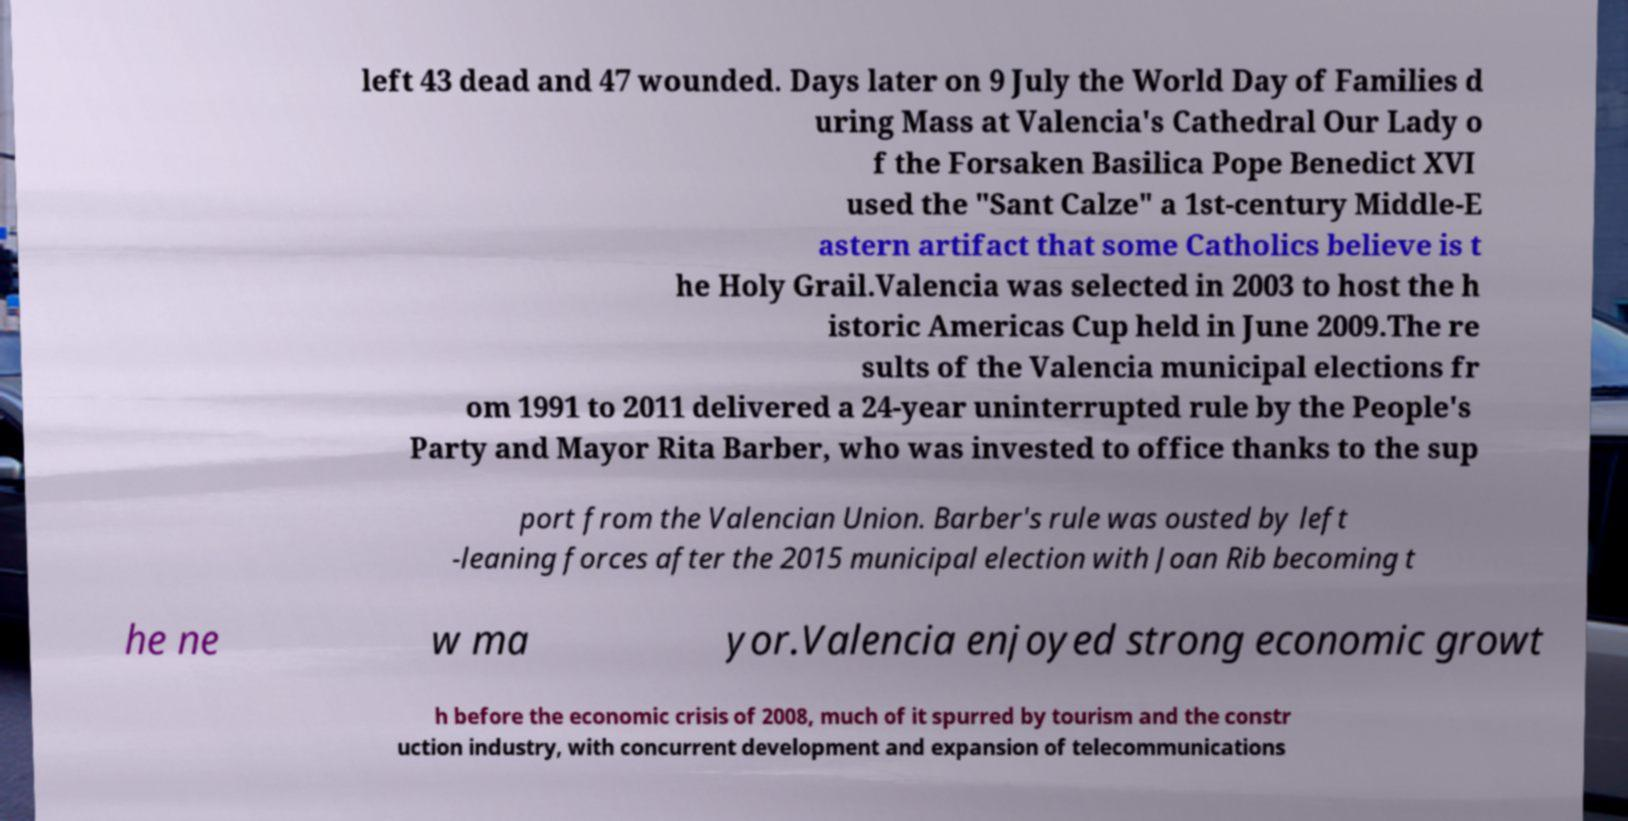Could you assist in decoding the text presented in this image and type it out clearly? left 43 dead and 47 wounded. Days later on 9 July the World Day of Families d uring Mass at Valencia's Cathedral Our Lady o f the Forsaken Basilica Pope Benedict XVI used the "Sant Calze" a 1st-century Middle-E astern artifact that some Catholics believe is t he Holy Grail.Valencia was selected in 2003 to host the h istoric Americas Cup held in June 2009.The re sults of the Valencia municipal elections fr om 1991 to 2011 delivered a 24-year uninterrupted rule by the People's Party and Mayor Rita Barber, who was invested to office thanks to the sup port from the Valencian Union. Barber's rule was ousted by left -leaning forces after the 2015 municipal election with Joan Rib becoming t he ne w ma yor.Valencia enjoyed strong economic growt h before the economic crisis of 2008, much of it spurred by tourism and the constr uction industry, with concurrent development and expansion of telecommunications 